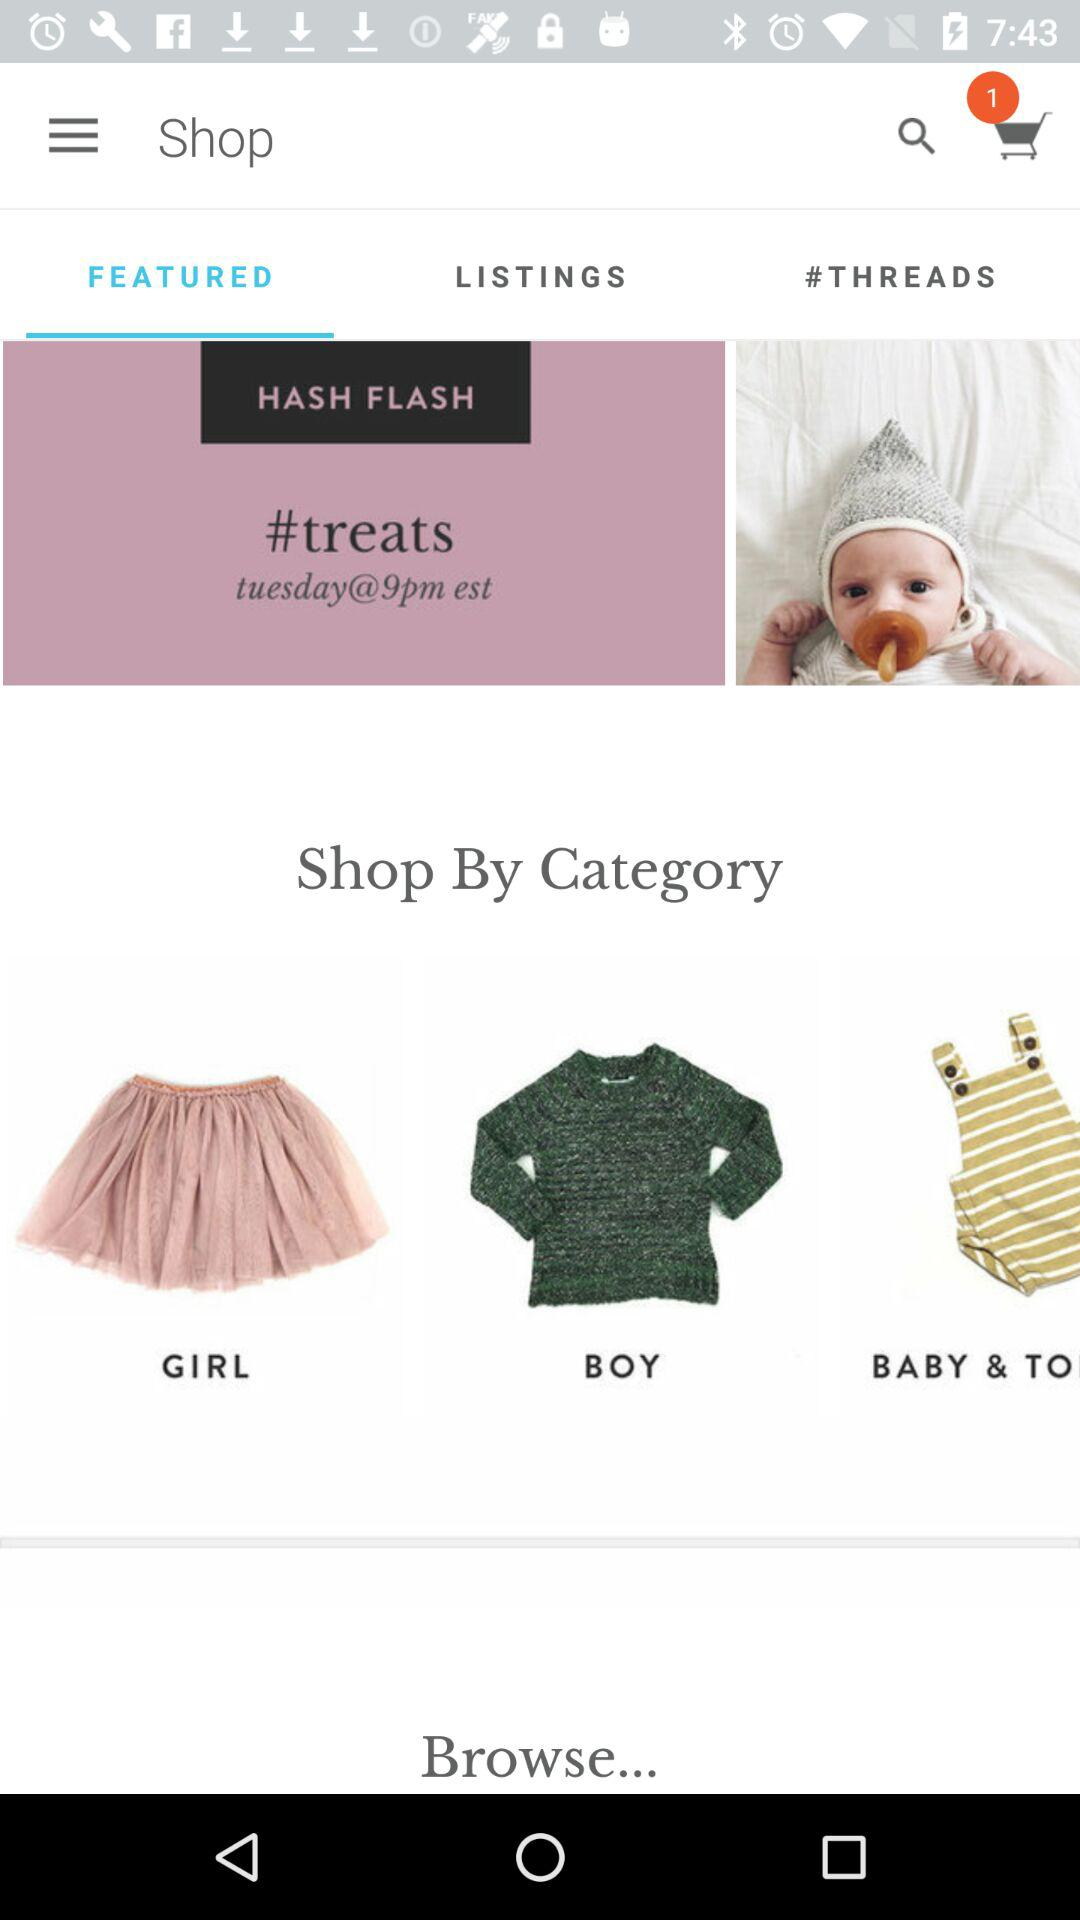How many items are in the cart? There is 1 item in the cart. 